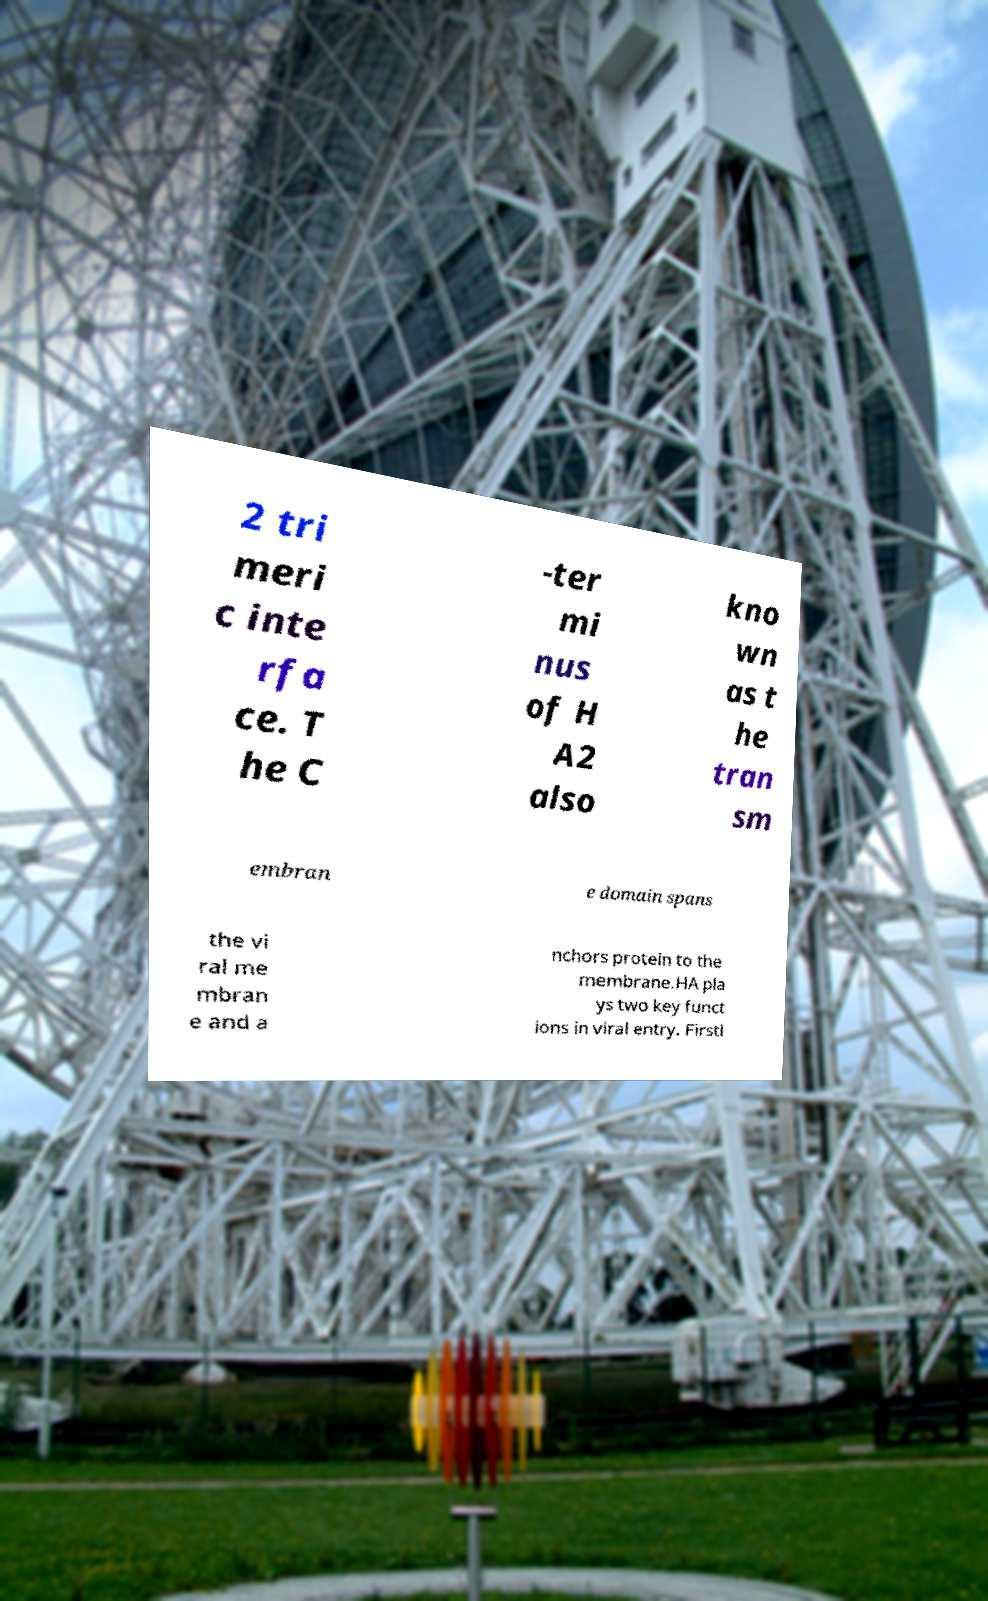Please identify and transcribe the text found in this image. 2 tri meri c inte rfa ce. T he C -ter mi nus of H A2 also kno wn as t he tran sm embran e domain spans the vi ral me mbran e and a nchors protein to the membrane.HA pla ys two key funct ions in viral entry. Firstl 